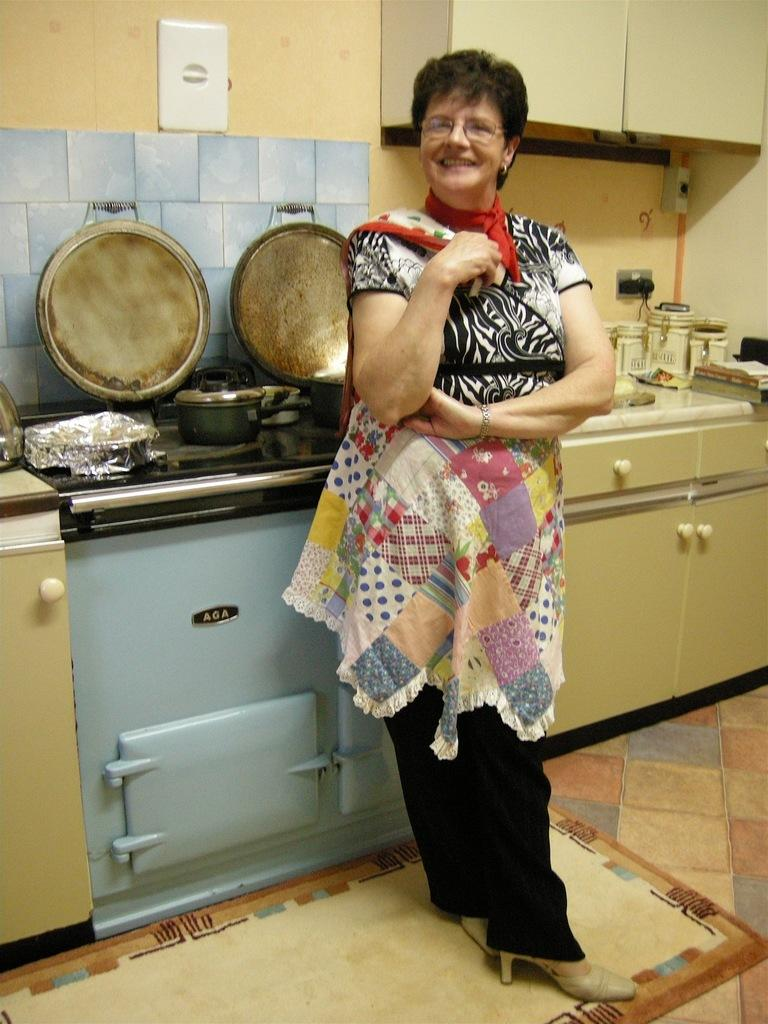Provide a one-sentence caption for the provided image. A woman stands in front of a blue AGA brand oven. 